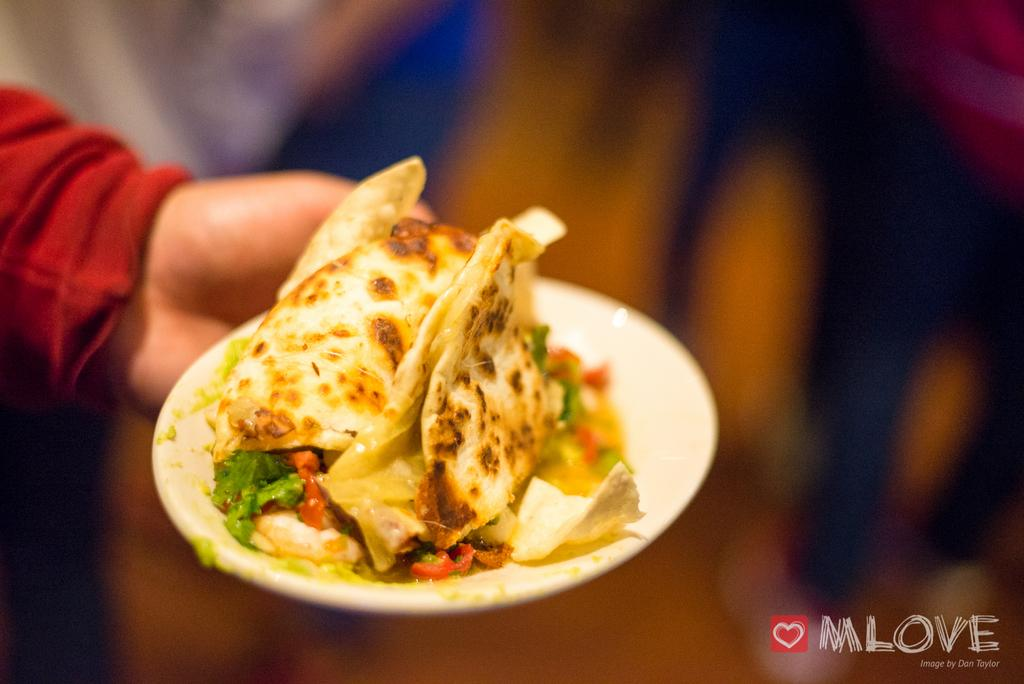Where was the image taken? The image was taken indoors. What can be observed about the background of the image? The background of the image is blurred. What is the person's hand holding in the image? There is a person's hand holding a plate in the image. What is on the plate that the person is holding? The plate contains food. What type of crime is being committed in the image? There is no crime being committed in the image; it simply shows a person holding a plate with food. How does the person start the meal in the image? The image does not show the person starting the meal, nor does it provide any information about how the meal will be consumed. 